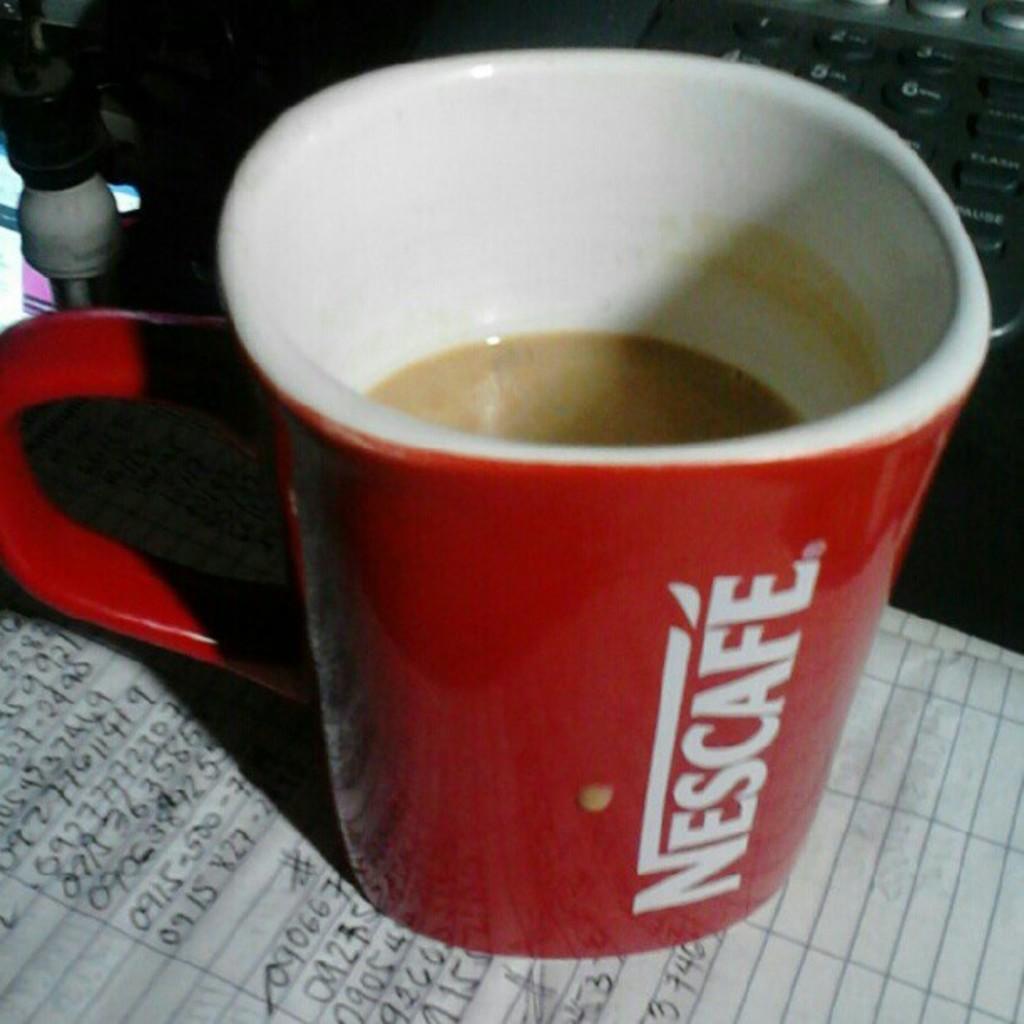What brand is written on this mug?
Provide a succinct answer. Nescafe. What type of beverage is this?
Your answer should be compact. Nescafe. 